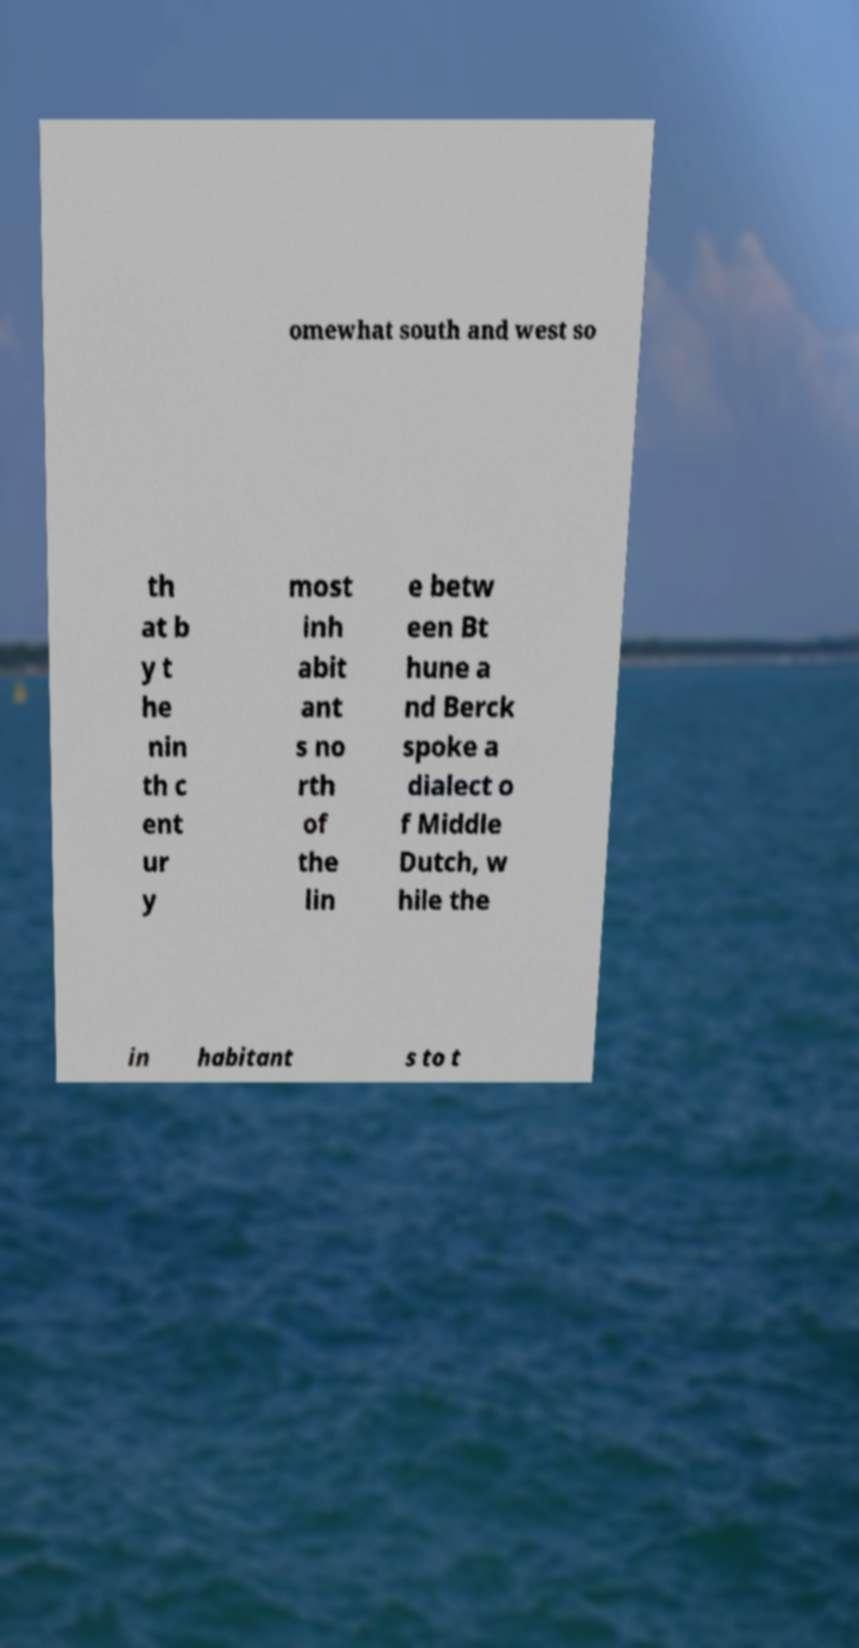Please read and relay the text visible in this image. What does it say? omewhat south and west so th at b y t he nin th c ent ur y most inh abit ant s no rth of the lin e betw een Bt hune a nd Berck spoke a dialect o f Middle Dutch, w hile the in habitant s to t 